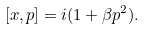Convert formula to latex. <formula><loc_0><loc_0><loc_500><loc_500>[ x , p ] = i ( 1 + \beta p ^ { 2 } ) .</formula> 